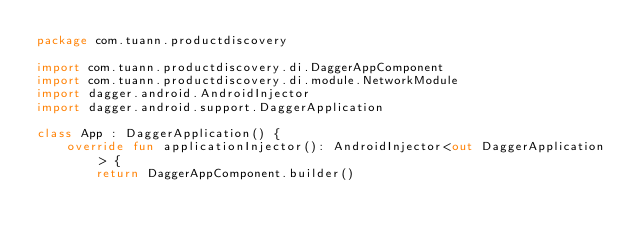<code> <loc_0><loc_0><loc_500><loc_500><_Kotlin_>package com.tuann.productdiscovery

import com.tuann.productdiscovery.di.DaggerAppComponent
import com.tuann.productdiscovery.di.module.NetworkModule
import dagger.android.AndroidInjector
import dagger.android.support.DaggerApplication

class App : DaggerApplication() {
    override fun applicationInjector(): AndroidInjector<out DaggerApplication> {
        return DaggerAppComponent.builder()</code> 